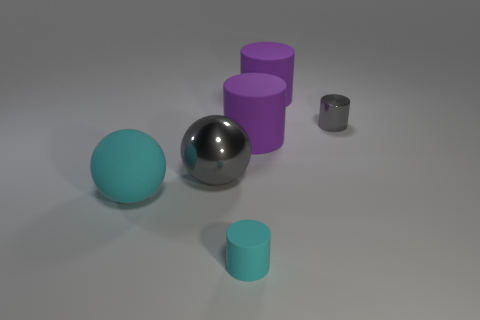Add 2 cyan rubber cylinders. How many objects exist? 8 Subtract all cylinders. How many objects are left? 2 Subtract all big purple rubber cylinders. Subtract all gray metallic spheres. How many objects are left? 3 Add 1 gray cylinders. How many gray cylinders are left? 2 Add 4 cyan metal cylinders. How many cyan metal cylinders exist? 4 Subtract 0 blue cylinders. How many objects are left? 6 